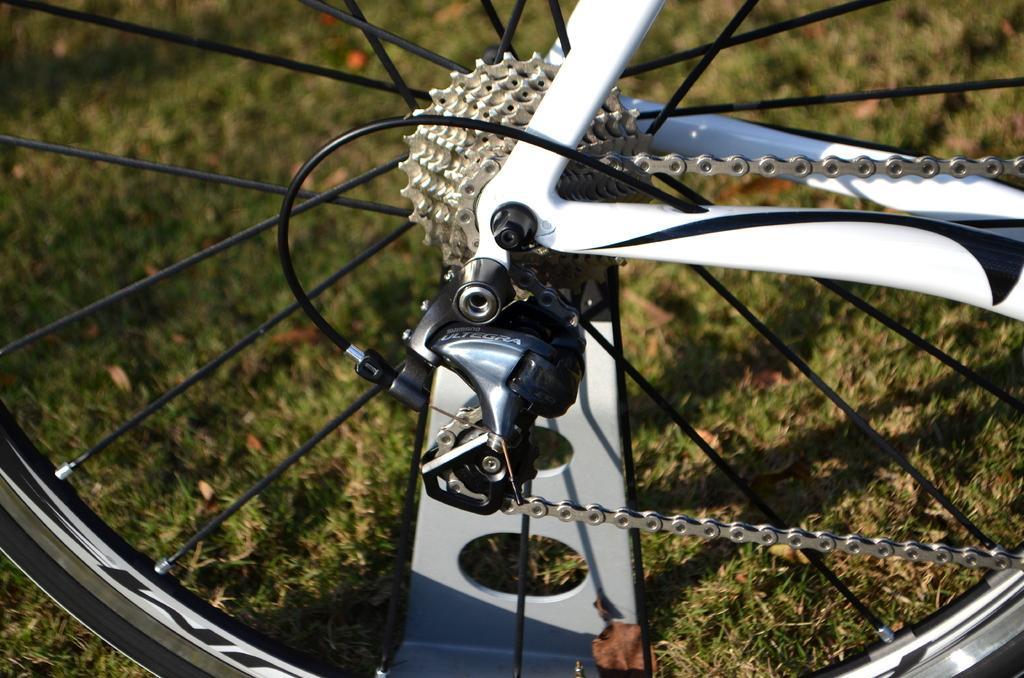Describe this image in one or two sentences. In this image there are parts of a bicycle wheel ,and in the background there is grass. 